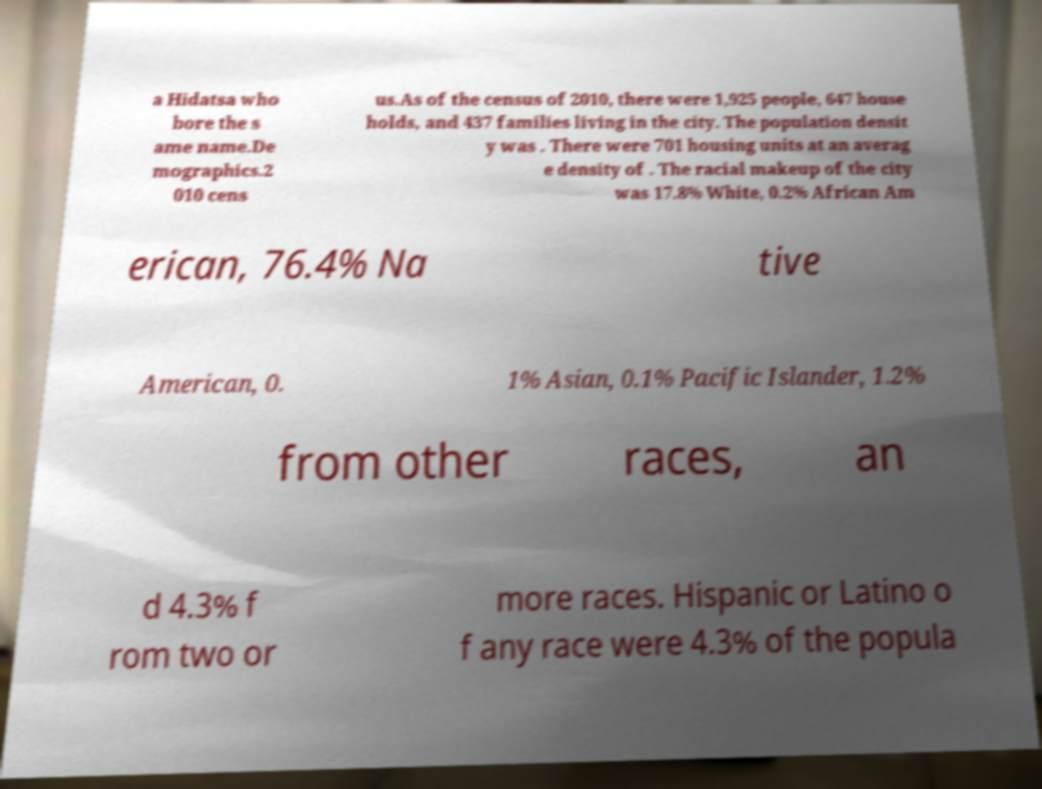I need the written content from this picture converted into text. Can you do that? a Hidatsa who bore the s ame name.De mographics.2 010 cens us.As of the census of 2010, there were 1,925 people, 647 house holds, and 437 families living in the city. The population densit y was . There were 701 housing units at an averag e density of . The racial makeup of the city was 17.8% White, 0.2% African Am erican, 76.4% Na tive American, 0. 1% Asian, 0.1% Pacific Islander, 1.2% from other races, an d 4.3% f rom two or more races. Hispanic or Latino o f any race were 4.3% of the popula 